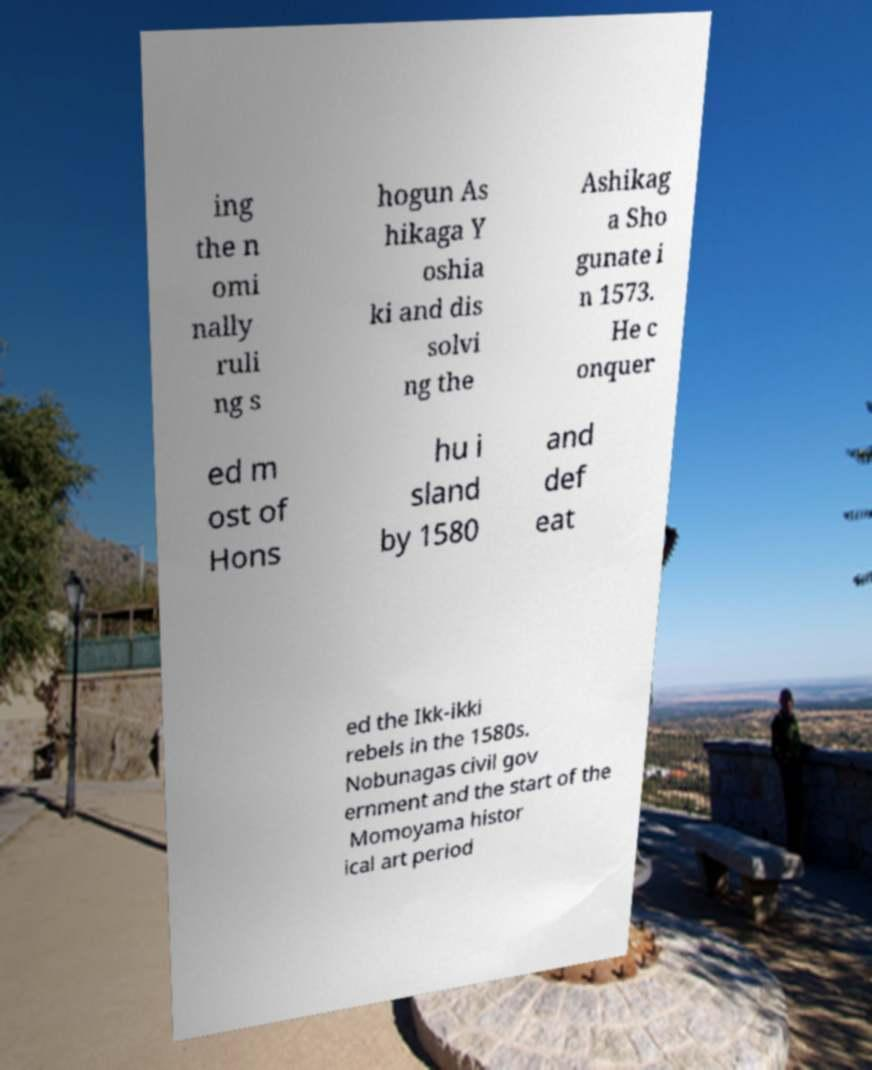There's text embedded in this image that I need extracted. Can you transcribe it verbatim? ing the n omi nally ruli ng s hogun As hikaga Y oshia ki and dis solvi ng the Ashikag a Sho gunate i n 1573. He c onquer ed m ost of Hons hu i sland by 1580 and def eat ed the Ikk-ikki rebels in the 1580s. Nobunagas civil gov ernment and the start of the Momoyama histor ical art period 